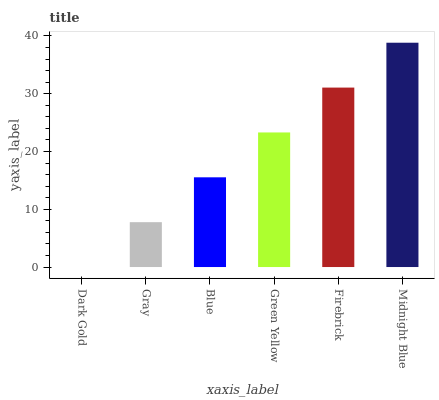Is Dark Gold the minimum?
Answer yes or no. Yes. Is Midnight Blue the maximum?
Answer yes or no. Yes. Is Gray the minimum?
Answer yes or no. No. Is Gray the maximum?
Answer yes or no. No. Is Gray greater than Dark Gold?
Answer yes or no. Yes. Is Dark Gold less than Gray?
Answer yes or no. Yes. Is Dark Gold greater than Gray?
Answer yes or no. No. Is Gray less than Dark Gold?
Answer yes or no. No. Is Green Yellow the high median?
Answer yes or no. Yes. Is Blue the low median?
Answer yes or no. Yes. Is Gray the high median?
Answer yes or no. No. Is Dark Gold the low median?
Answer yes or no. No. 